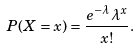Convert formula to latex. <formula><loc_0><loc_0><loc_500><loc_500>P ( X = x ) = \frac { e ^ { - \lambda } \lambda ^ { x } } { x ! } .</formula> 